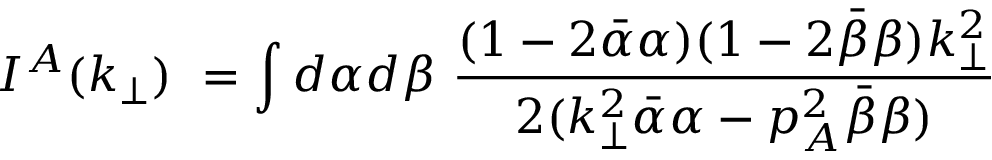<formula> <loc_0><loc_0><loc_500><loc_500>I ^ { A } ( k _ { \perp } ) = \int d \alpha d \beta { \frac { ( 1 - 2 \bar { \alpha } \alpha ) ( 1 - 2 \bar { \beta } \beta ) k _ { \perp } ^ { 2 } } { 2 ( k _ { \perp } ^ { 2 } \bar { \alpha } \alpha - p _ { A } ^ { 2 } \bar { \beta } \beta ) } }</formula> 